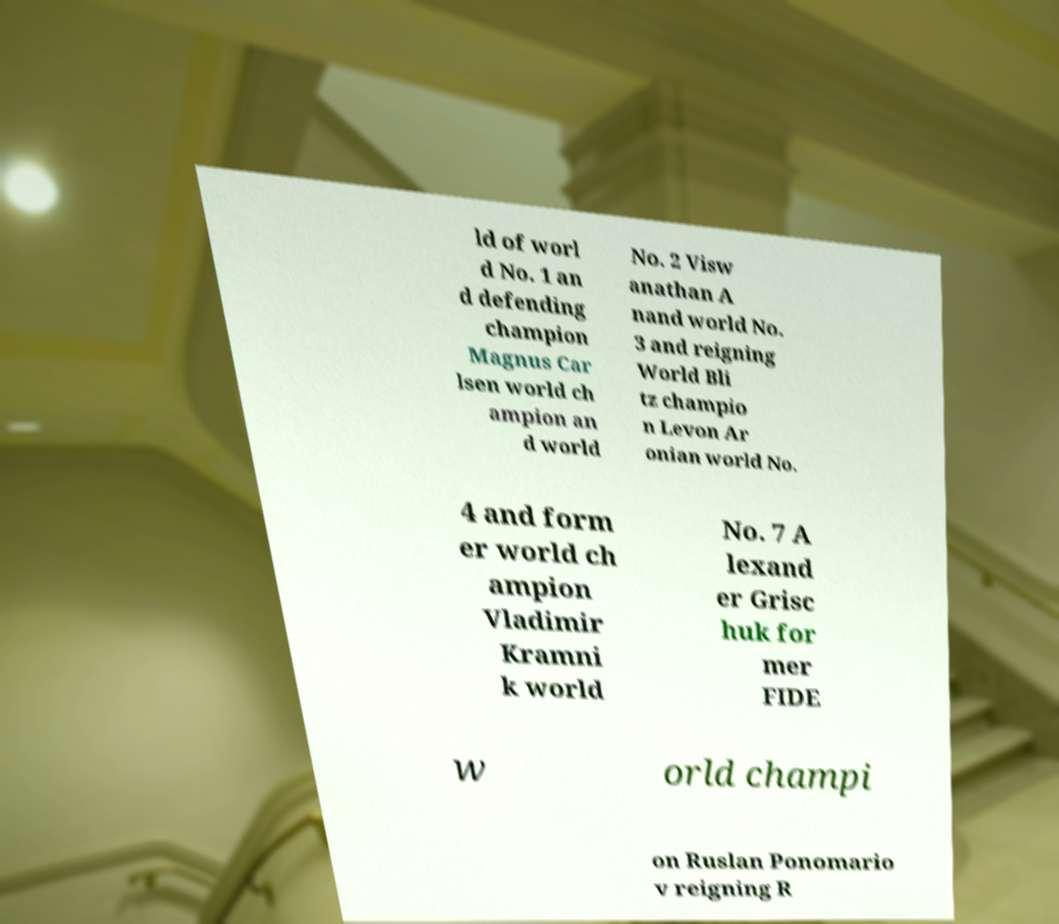For documentation purposes, I need the text within this image transcribed. Could you provide that? ld of worl d No. 1 an d defending champion Magnus Car lsen world ch ampion an d world No. 2 Visw anathan A nand world No. 3 and reigning World Bli tz champio n Levon Ar onian world No. 4 and form er world ch ampion Vladimir Kramni k world No. 7 A lexand er Grisc huk for mer FIDE w orld champi on Ruslan Ponomario v reigning R 